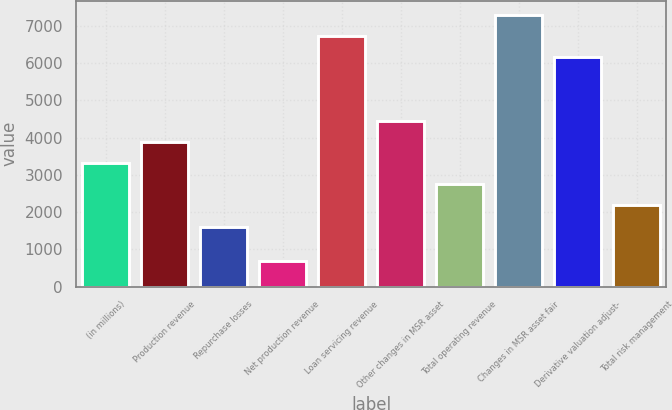<chart> <loc_0><loc_0><loc_500><loc_500><bar_chart><fcel>(in millions)<fcel>Production revenue<fcel>Repurchase losses<fcel>Net production revenue<fcel>Loan servicing revenue<fcel>Other changes in MSR asset<fcel>Total operating revenue<fcel>Changes in MSR asset fair<fcel>Derivative valuation adjust-<fcel>Total risk management<nl><fcel>3318.4<fcel>3887.2<fcel>1612<fcel>684.8<fcel>6731.2<fcel>4456<fcel>2749.6<fcel>7300<fcel>6162.4<fcel>2180.8<nl></chart> 